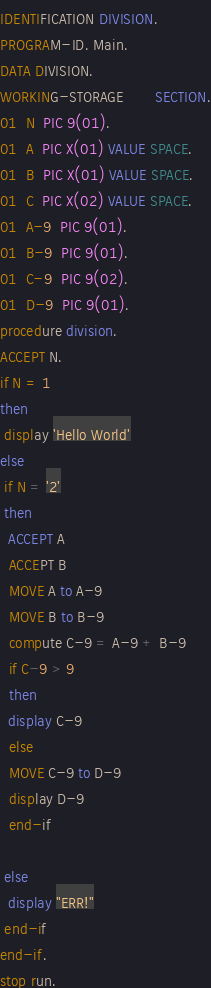Convert code to text. <code><loc_0><loc_0><loc_500><loc_500><_COBOL_>IDENTIFICATION DIVISION.
PROGRAM-ID. Main.
DATA DIVISION.
WORKING-STORAGE       SECTION.
01  N  PIC 9(01).
01  A  PIC X(01) VALUE SPACE.
01  B  PIC X(01) VALUE SPACE.
01  C  PIC X(02) VALUE SPACE.
01  A-9  PIC 9(01).
01  B-9  PIC 9(01).
01  C-9  PIC 9(02).
01  D-9  PIC 9(01).
procedure division.
ACCEPT N.
if N = 1
then
 display 'Hello World'
else
 if N = '2'
 then
  ACCEPT A
  ACCEPT B
  MOVE A to A-9 
  MOVE B to B-9
  compute C-9 = A-9 + B-9
  if C-9 > 9
  then
  display C-9
  else
  MOVE C-9 to D-9
  display D-9
  end-if
  
 else
  display "ERR!"
 end-if
end-if.
stop run.

</code> 